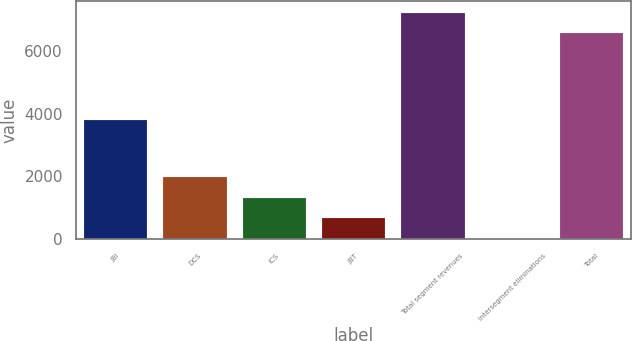Convert chart. <chart><loc_0><loc_0><loc_500><loc_500><bar_chart><fcel>JBI<fcel>DCS<fcel>ICS<fcel>JBT<fcel>Total segment revenues<fcel>Intersegment eliminations<fcel>Total<nl><fcel>3796<fcel>1980.5<fcel>1325<fcel>669.5<fcel>7210.5<fcel>14<fcel>6555<nl></chart> 